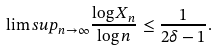<formula> <loc_0><loc_0><loc_500><loc_500>\lim s u p _ { n \rightarrow \infty } \frac { \log X _ { n } } { \log n } \leq \frac { 1 } { 2 \delta - 1 } .</formula> 